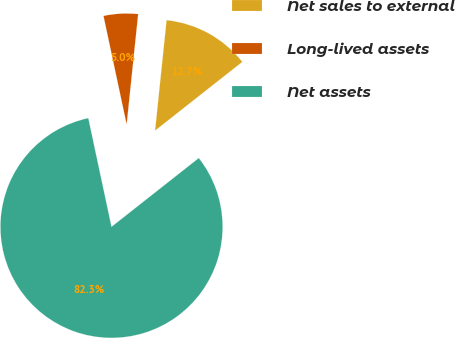Convert chart. <chart><loc_0><loc_0><loc_500><loc_500><pie_chart><fcel>Net sales to external<fcel>Long-lived assets<fcel>Net assets<nl><fcel>12.73%<fcel>5.0%<fcel>82.28%<nl></chart> 